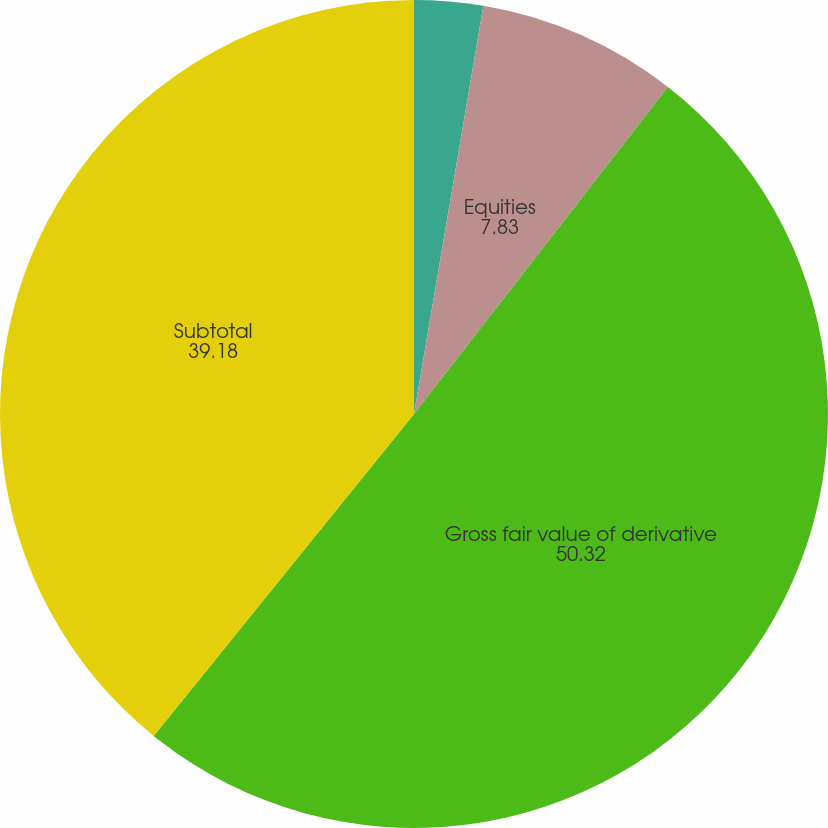Convert chart to OTSL. <chart><loc_0><loc_0><loc_500><loc_500><pie_chart><fcel>Interest rates<fcel>Equities<fcel>Gross fair value of derivative<fcel>Subtotal<nl><fcel>2.68%<fcel>7.83%<fcel>50.32%<fcel>39.18%<nl></chart> 